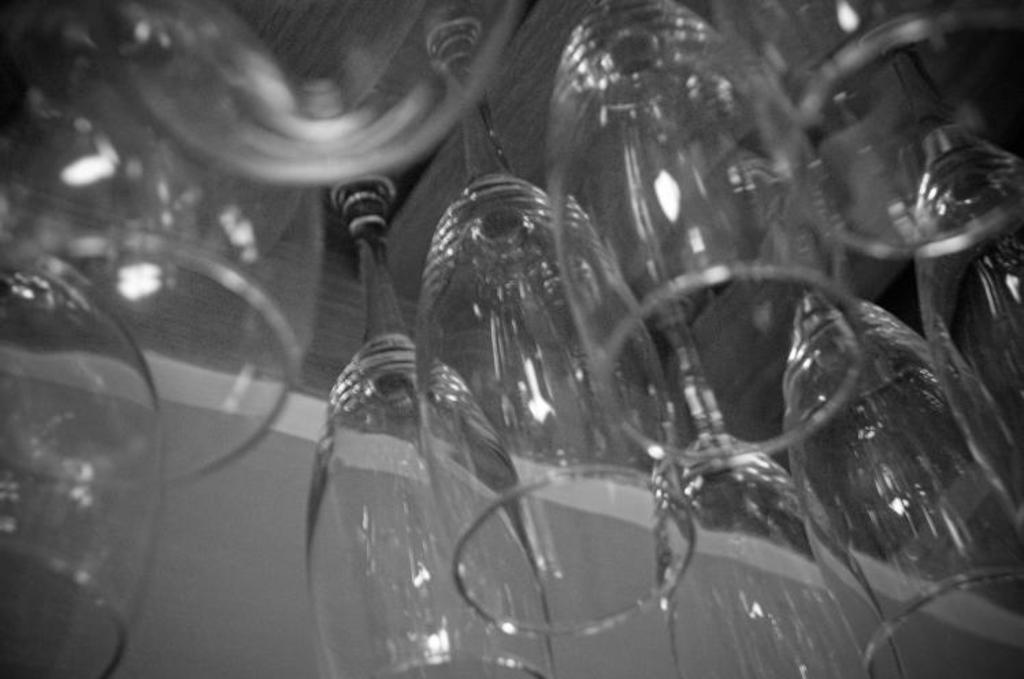Could you give a brief overview of what you see in this image? In this image there are glasses. 